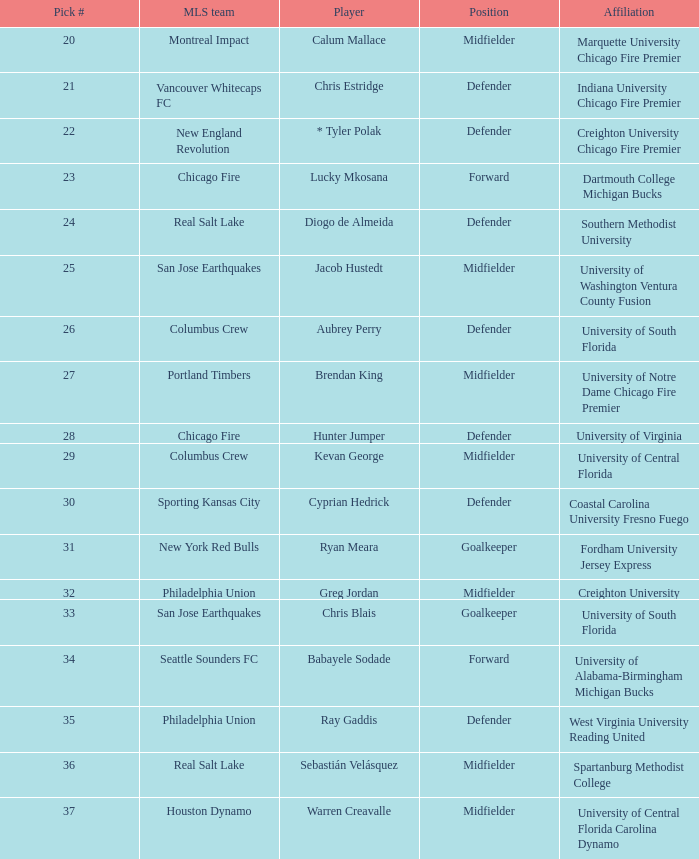What pick number did Real Salt Lake get? 24.0. 